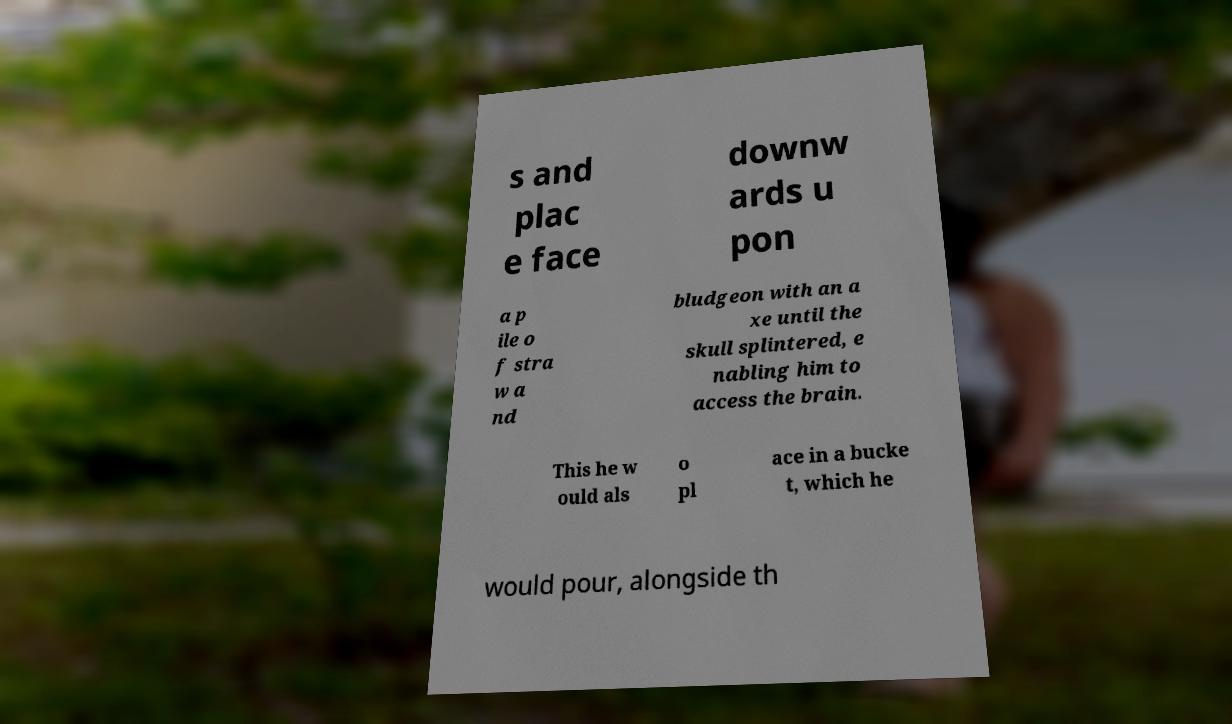Can you read and provide the text displayed in the image?This photo seems to have some interesting text. Can you extract and type it out for me? s and plac e face downw ards u pon a p ile o f stra w a nd bludgeon with an a xe until the skull splintered, e nabling him to access the brain. This he w ould als o pl ace in a bucke t, which he would pour, alongside th 